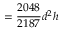Convert formula to latex. <formula><loc_0><loc_0><loc_500><loc_500>= { \frac { 2 0 4 8 } { 2 1 8 7 } } d ^ { 2 } h</formula> 